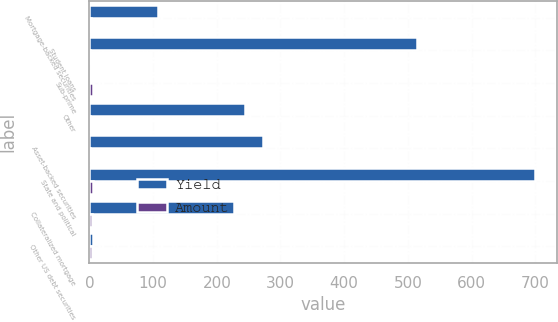Convert chart. <chart><loc_0><loc_0><loc_500><loc_500><stacked_bar_chart><ecel><fcel>Mortgage-backed securities<fcel>Student loans<fcel>Sub-prime<fcel>Other<fcel>Asset-backed securities<fcel>State and political<fcel>Collateralized mortgage<fcel>Other US debt securities<nl><fcel>Yield<fcel>107<fcel>515<fcel>3<fcel>244<fcel>272<fcel>699<fcel>227<fcel>4.86<nl><fcel>Amount<fcel>2.75<fcel>0.9<fcel>4.86<fcel>0.51<fcel>1.01<fcel>4.96<fcel>4.56<fcel>4.02<nl></chart> 